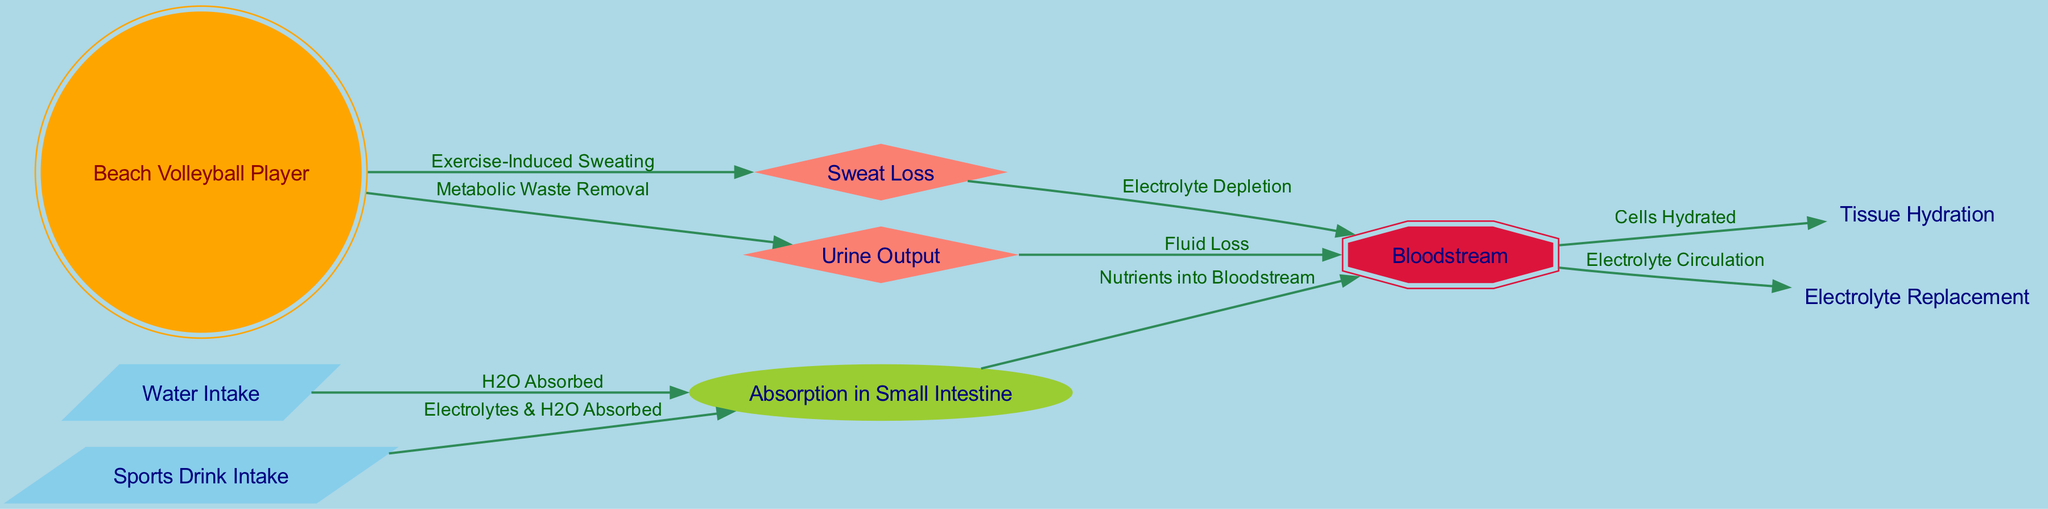What is the first step for a beach volleyball player in hydration? The first step in the diagram is "Water Intake," as indicated by the initial node that represents the action of consuming water.
Answer: Water Intake How many nodes are there in total? By counting all the unique nodes in the diagram, including the beach volleyball player and all connections for hydration, we find a total of 9 nodes.
Answer: 9 What happens to nutrients after absorption in the small intestine? According to the flowchart, after absorption in the small intestine, the nutrients are transferred to the bloodstream, as shown by the corresponding edge labeled "Nutrients into Bloodstream."
Answer: Bloodstream Which component leads to tissue hydration? The edge connecting the bloodstream to the tissue hydration node states that the bloodstream provides hydration to cells, making "Bloodstream" the relevant component that leads to tissue hydration.
Answer: Bloodstream What is lost through sweat during beach volleyball play? The diagram specifies "Electrolyte Depletion" as a result of sweat loss, making it the key outcome associated with sweating during exercise.
Answer: Electrolyte Depletion What is the effect of metabolic waste removal? The metabolic waste removal, represented by the urine output node, indicates that fluid loss occurs, leading to the loss of necessary hydration from the body.
Answer: Fluid Loss How do sports drinks affect hydration? Sports drinks contribute to hydration by not only providing water but also electrolytes, which are absorbed in the small intestine, indicating their dual role in enhancing hydration.
Answer: Electrolytes & H2O Absorbed What process leads to electrolyte circulation in the body? The movement of nutrients into the bloodstream leads to electrolyte circulation as indicated by the flow from the bloodstream to the electrolyte replacement node, showcasing the connection between nutrient absorption and electrolyte levels.
Answer: Electrolyte Circulation 